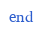Convert code to text. <code><loc_0><loc_0><loc_500><loc_500><_Ruby_>end
</code> 